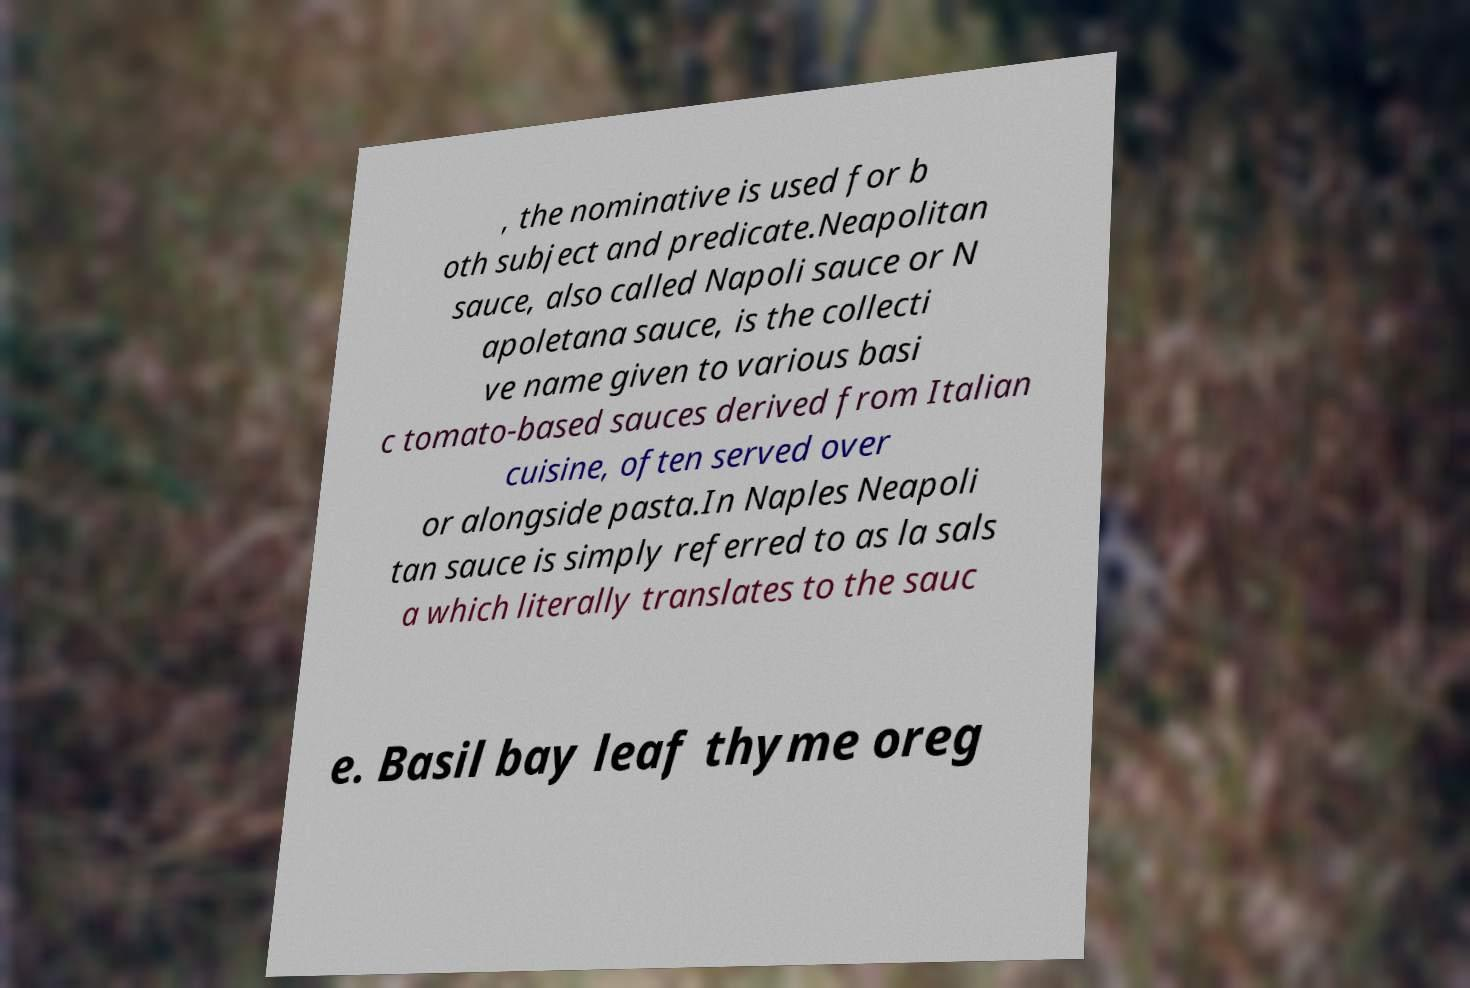Could you assist in decoding the text presented in this image and type it out clearly? , the nominative is used for b oth subject and predicate.Neapolitan sauce, also called Napoli sauce or N apoletana sauce, is the collecti ve name given to various basi c tomato-based sauces derived from Italian cuisine, often served over or alongside pasta.In Naples Neapoli tan sauce is simply referred to as la sals a which literally translates to the sauc e. Basil bay leaf thyme oreg 